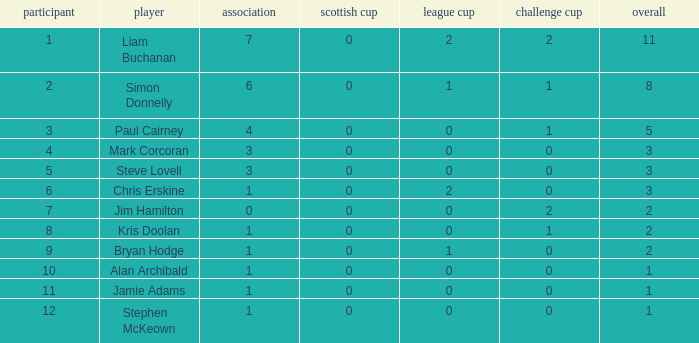What is bryan hodge's player number 1.0. 